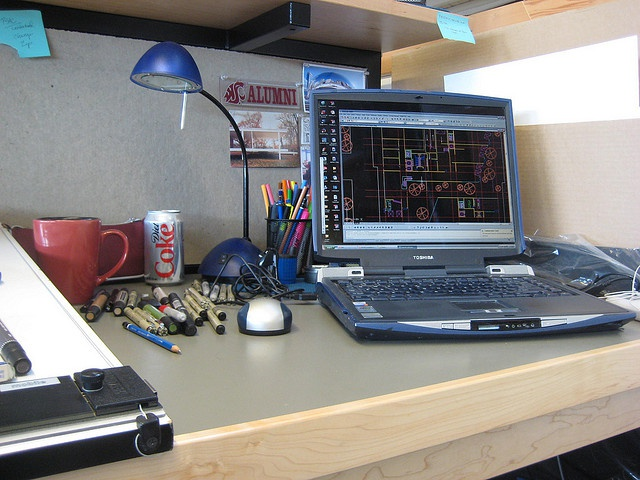Describe the objects in this image and their specific colors. I can see laptop in black, gray, and blue tones, cup in black, maroon, and brown tones, and mouse in black, white, darkgray, and gray tones in this image. 